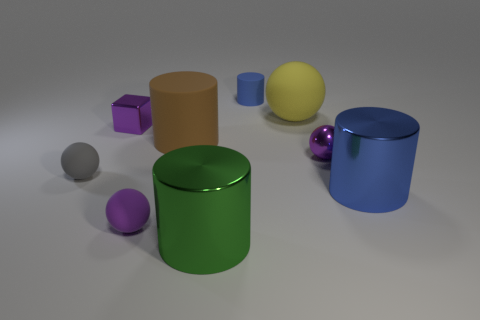There is a big thing that is left of the big metal cylinder that is to the left of the small blue rubber cylinder; how many purple things are behind it?
Provide a short and direct response. 1. Do the matte ball to the right of the large green cylinder and the purple shiny object left of the big green object have the same size?
Provide a short and direct response. No. There is another large thing that is the same shape as the gray matte thing; what material is it?
Your answer should be very brief. Rubber. How many big things are green cylinders or purple spheres?
Your answer should be very brief. 1. What is the material of the tiny purple block?
Ensure brevity in your answer.  Metal. What material is the purple object that is left of the yellow rubber object and in front of the large rubber cylinder?
Offer a terse response. Rubber. Do the cube and the tiny metal thing on the right side of the metal block have the same color?
Ensure brevity in your answer.  Yes. What material is the gray object that is the same size as the block?
Provide a short and direct response. Rubber. Is there a green cylinder made of the same material as the big yellow thing?
Ensure brevity in your answer.  No. What number of large red matte cylinders are there?
Your response must be concise. 0. 